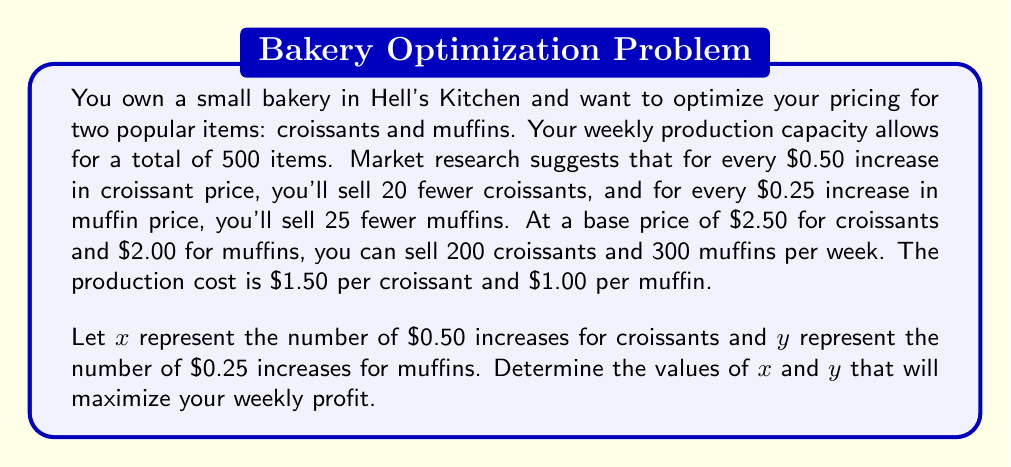Can you answer this question? Let's approach this step-by-step:

1) First, we need to express the number of croissants and muffins sold as a function of $x$ and $y$:
   Croissants sold: $200 - 20x$
   Muffins sold: $300 - 25y$

2) The prices can be expressed as:
   Croissant price: $2.50 + 0.50x$
   Muffin price: $2.00 + 0.25y$

3) Now, let's set up the profit function. Profit = Revenue - Cost
   $$P = (2.50 + 0.50x)(200 - 20x) + (2.00 + 0.25y)(300 - 25y) - 1.50(200 - 20x) - 1.00(300 - 25y)$$

4) Simplify:
   $$P = (500 + 50x - 50x - 5x^2) + (600 + 75y - 50y - 6.25y^2) - 300 + 30x - 300 + 25y$$
   $$P = 500 - 5x^2 + 30x + 600 - 6.25y^2 + 50y - 600$$
   $$P = 500 - 5x^2 + 30x - 6.25y^2 + 50y$$

5) To maximize profit, we need to find where the partial derivatives equal zero:
   $$\frac{\partial P}{\partial x} = -10x + 30 = 0$$
   $$\frac{\partial P}{\partial y} = -12.5y + 50 = 0$$

6) Solve these equations:
   $$x = 3$$
   $$y = 4$$

7) Check the second derivatives to confirm this is a maximum:
   $$\frac{\partial^2 P}{\partial x^2} = -10 < 0$$
   $$\frac{\partial^2 P}{\partial y^2} = -12.5 < 0$$

   Both are negative, confirming a maximum.

8) Calculate the optimal quantities and prices:
   Croissants: 200 - 20(3) = 140 at $2.50 + 0.50(3) = $4.00 each
   Muffins: 300 - 25(4) = 200 at $2.00 + 0.25(4) = $3.00 each

9) Verify that total production is within capacity:
   140 + 200 = 340 < 500, so this solution is feasible.
Answer: The optimal pricing strategy is to sell croissants at $4.00 each and muffins at $3.00 each. This corresponds to $x = 3$ (three $0.50 increases for croissants) and $y = 4$ (four $0.25 increases for muffins). 